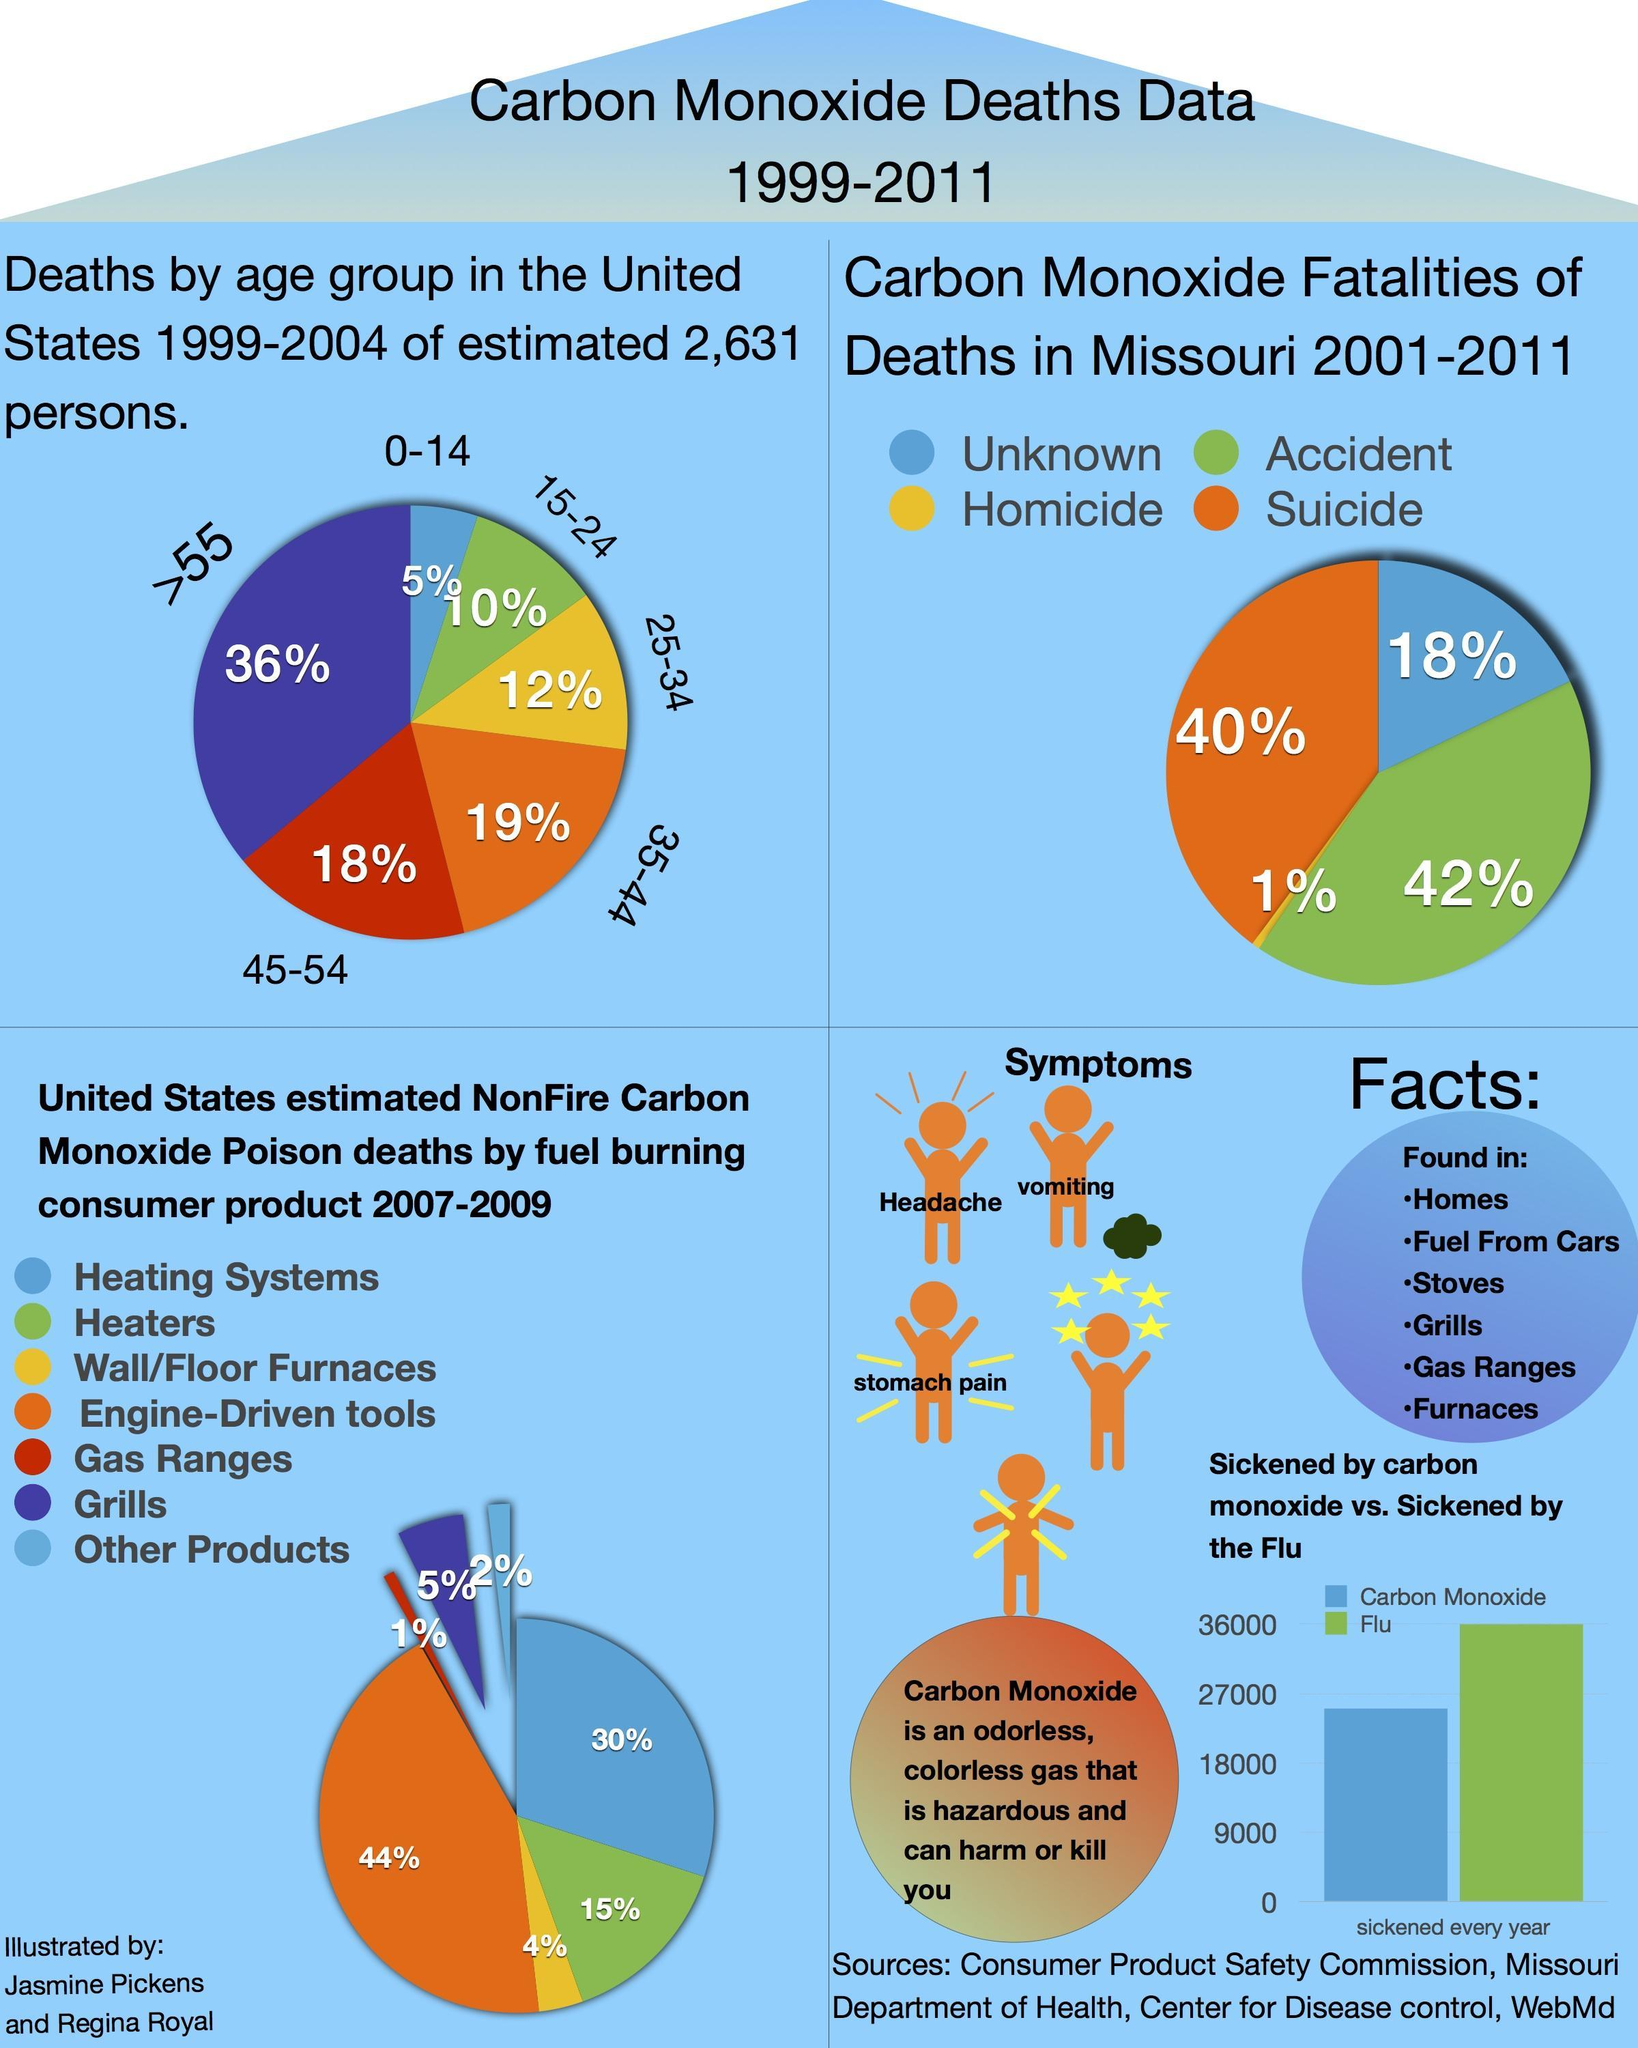What is the difference in number of people taking ill due to Flu and Carbon Monoxide?
Answer the question with a short phrase. 11000 What was the second lowest percentage of death? 10% What is the mortality rate due to heating systems and other products? 32% Which consumer product contributed to the highest percentage of NonFire Carbon Monoxide Poison deaths? Engine-Driven tools What are the symptoms of sickness caused due to Carbon Monoxide ? Headache, vomiting, stomach pain What percentage of carbon monoxide deaths in Missouri are due to homocide? 1% What percentage of people between 25 and 44 dies due to Carbon Monoxide? 31% Which age group had the highest number of deaths due to Carbon Monoxide, 55+, 45-54, or 35-44? 55+ 